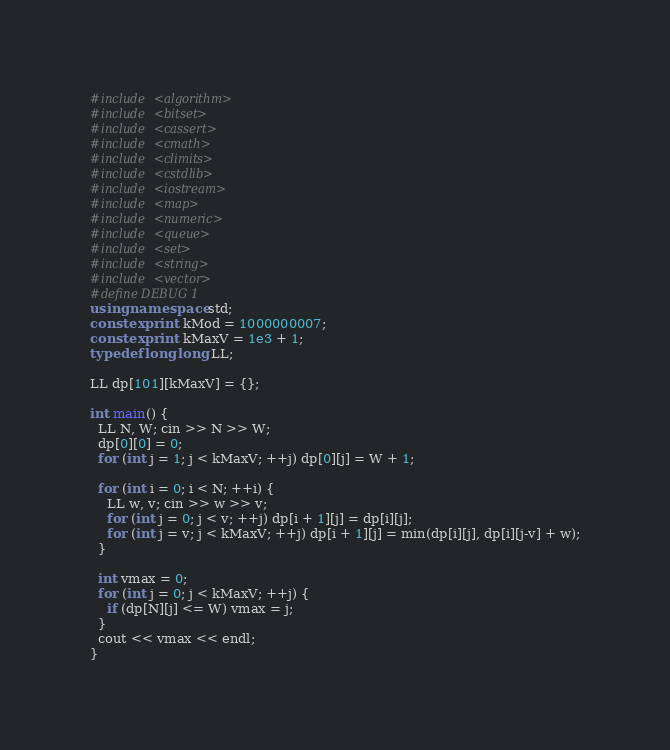<code> <loc_0><loc_0><loc_500><loc_500><_C++_>#include <algorithm>
#include <bitset>
#include <cassert>
#include <cmath>
#include <climits>
#include <cstdlib>
#include <iostream>
#include <map>
#include <numeric>
#include <queue>
#include <set>
#include <string>
#include <vector>
#define DEBUG 1
using namespace std;
constexpr int kMod = 1000000007;
constexpr int kMaxV = 1e3 + 1;
typedef long long LL;

LL dp[101][kMaxV] = {};

int main() {
  LL N, W; cin >> N >> W;
  dp[0][0] = 0;
  for (int j = 1; j < kMaxV; ++j) dp[0][j] = W + 1;

  for (int i = 0; i < N; ++i) {
    LL w, v; cin >> w >> v;
    for (int j = 0; j < v; ++j) dp[i + 1][j] = dp[i][j];
    for (int j = v; j < kMaxV; ++j) dp[i + 1][j] = min(dp[i][j], dp[i][j-v] + w);
  }

  int vmax = 0;
  for (int j = 0; j < kMaxV; ++j) {
    if (dp[N][j] <= W) vmax = j;
  }
  cout << vmax << endl;
}
</code> 